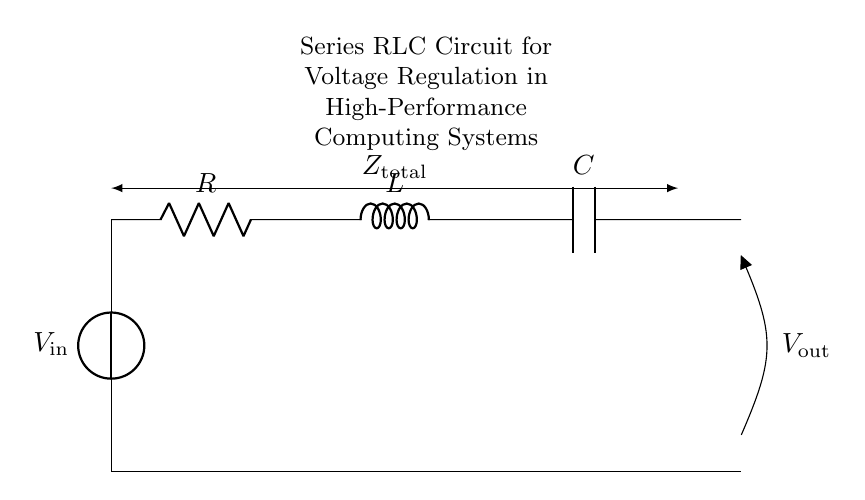What is the type of circuit depicted? The circuit is a series RLC circuit, as it consists of a resistor, inductor, and capacitor arranged in series. The diagram indicates the connection between the components and their sequential order.
Answer: series RLC circuit What component is labeled R? The component labeled R in the circuit diagram represents a resistor, which is used to limit the current flowing through the circuit. Its position in the series indicates its role in voltage regulation.
Answer: resistor What are the components of this circuit? The components in the circuit include a resistor, an inductor, and a capacitor. They are standard components used for filtering and voltage regulation, especially in high-performance applications.
Answer: resistor, inductor, capacitor What is the purpose of the inductor in this circuit? The inductor primarily provides energy storage in the magnetic field and helps to filter out high-frequency noise. In series configurations, it also contributes to the total impedance of the circuit.
Answer: energy storage How does the total impedance affect the performance of the circuit? The total impedance, which is the combination of resistive, inductive, and capacitive reactance, determines how much current flows for a given voltage applied across the circuit. A higher impedance can lead to reduced current, affecting voltage regulation.
Answer: it determines current flow What is the significance of voltage regulation in high-performance computing systems? Voltage regulation is crucial for ensuring stable operation and preventing fluctuations that can affect sensitive electronic components. In high-performance computing, consistent voltage is necessary for optimal performance and reliability.
Answer: stable operation 